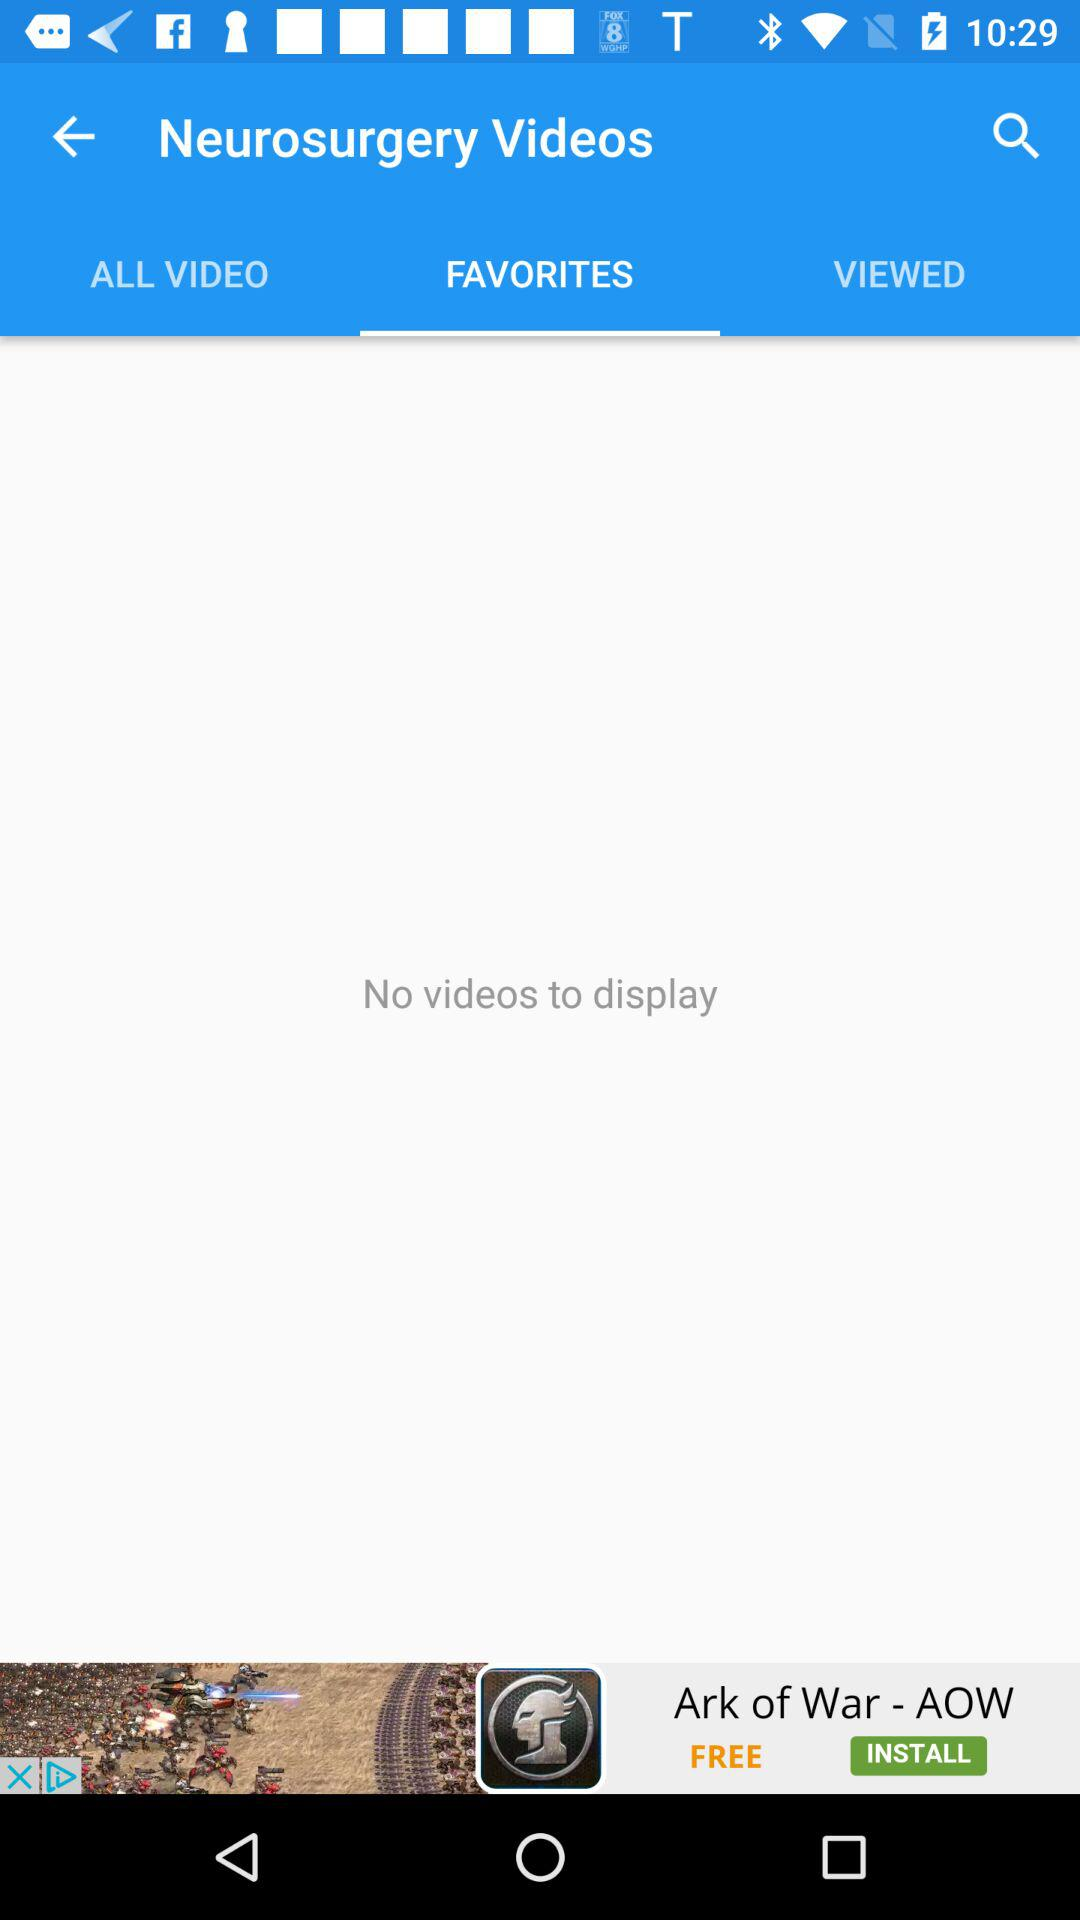How many videos are displayed?
Answer the question using a single word or phrase. 0 